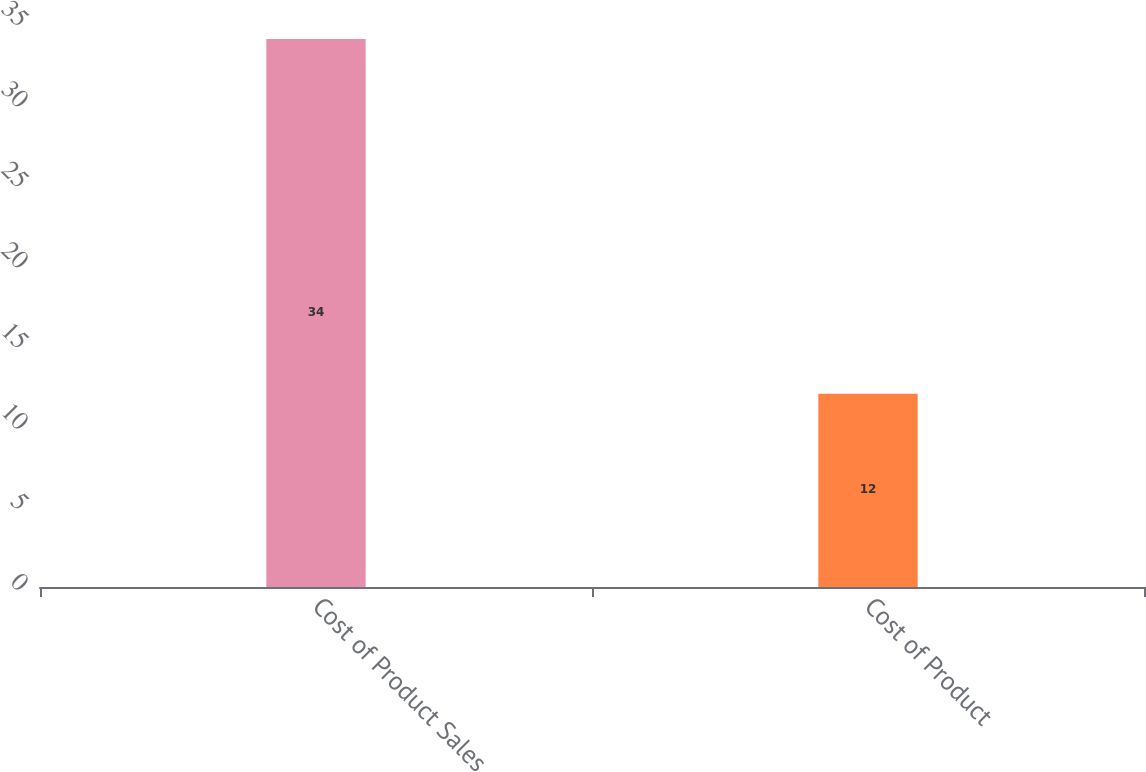Convert chart. <chart><loc_0><loc_0><loc_500><loc_500><bar_chart><fcel>Cost of Product Sales<fcel>Cost of Product<nl><fcel>34<fcel>12<nl></chart> 